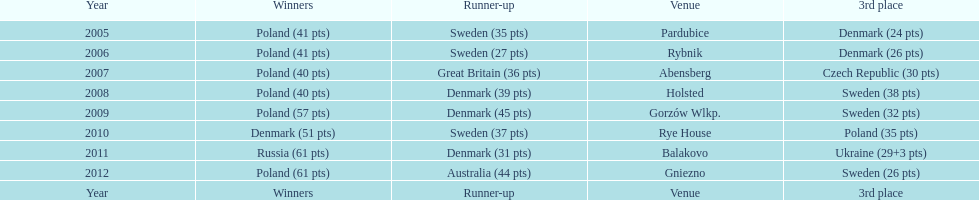When was the first year that poland did not place in the top three positions of the team speedway junior world championship? 2011. Could you parse the entire table? {'header': ['Year', 'Winners', 'Runner-up', 'Venue', '3rd place'], 'rows': [['2005', 'Poland (41 pts)', 'Sweden (35 pts)', 'Pardubice', 'Denmark (24 pts)'], ['2006', 'Poland (41 pts)', 'Sweden (27 pts)', 'Rybnik', 'Denmark (26 pts)'], ['2007', 'Poland (40 pts)', 'Great Britain (36 pts)', 'Abensberg', 'Czech Republic (30 pts)'], ['2008', 'Poland (40 pts)', 'Denmark (39 pts)', 'Holsted', 'Sweden (38 pts)'], ['2009', 'Poland (57 pts)', 'Denmark (45 pts)', 'Gorzów Wlkp.', 'Sweden (32 pts)'], ['2010', 'Denmark (51 pts)', 'Sweden (37 pts)', 'Rye House', 'Poland (35 pts)'], ['2011', 'Russia (61 pts)', 'Denmark (31 pts)', 'Balakovo', 'Ukraine (29+3 pts)'], ['2012', 'Poland (61 pts)', 'Australia (44 pts)', 'Gniezno', 'Sweden (26 pts)'], ['Year', 'Winners', 'Runner-up', 'Venue', '3rd place']]} 